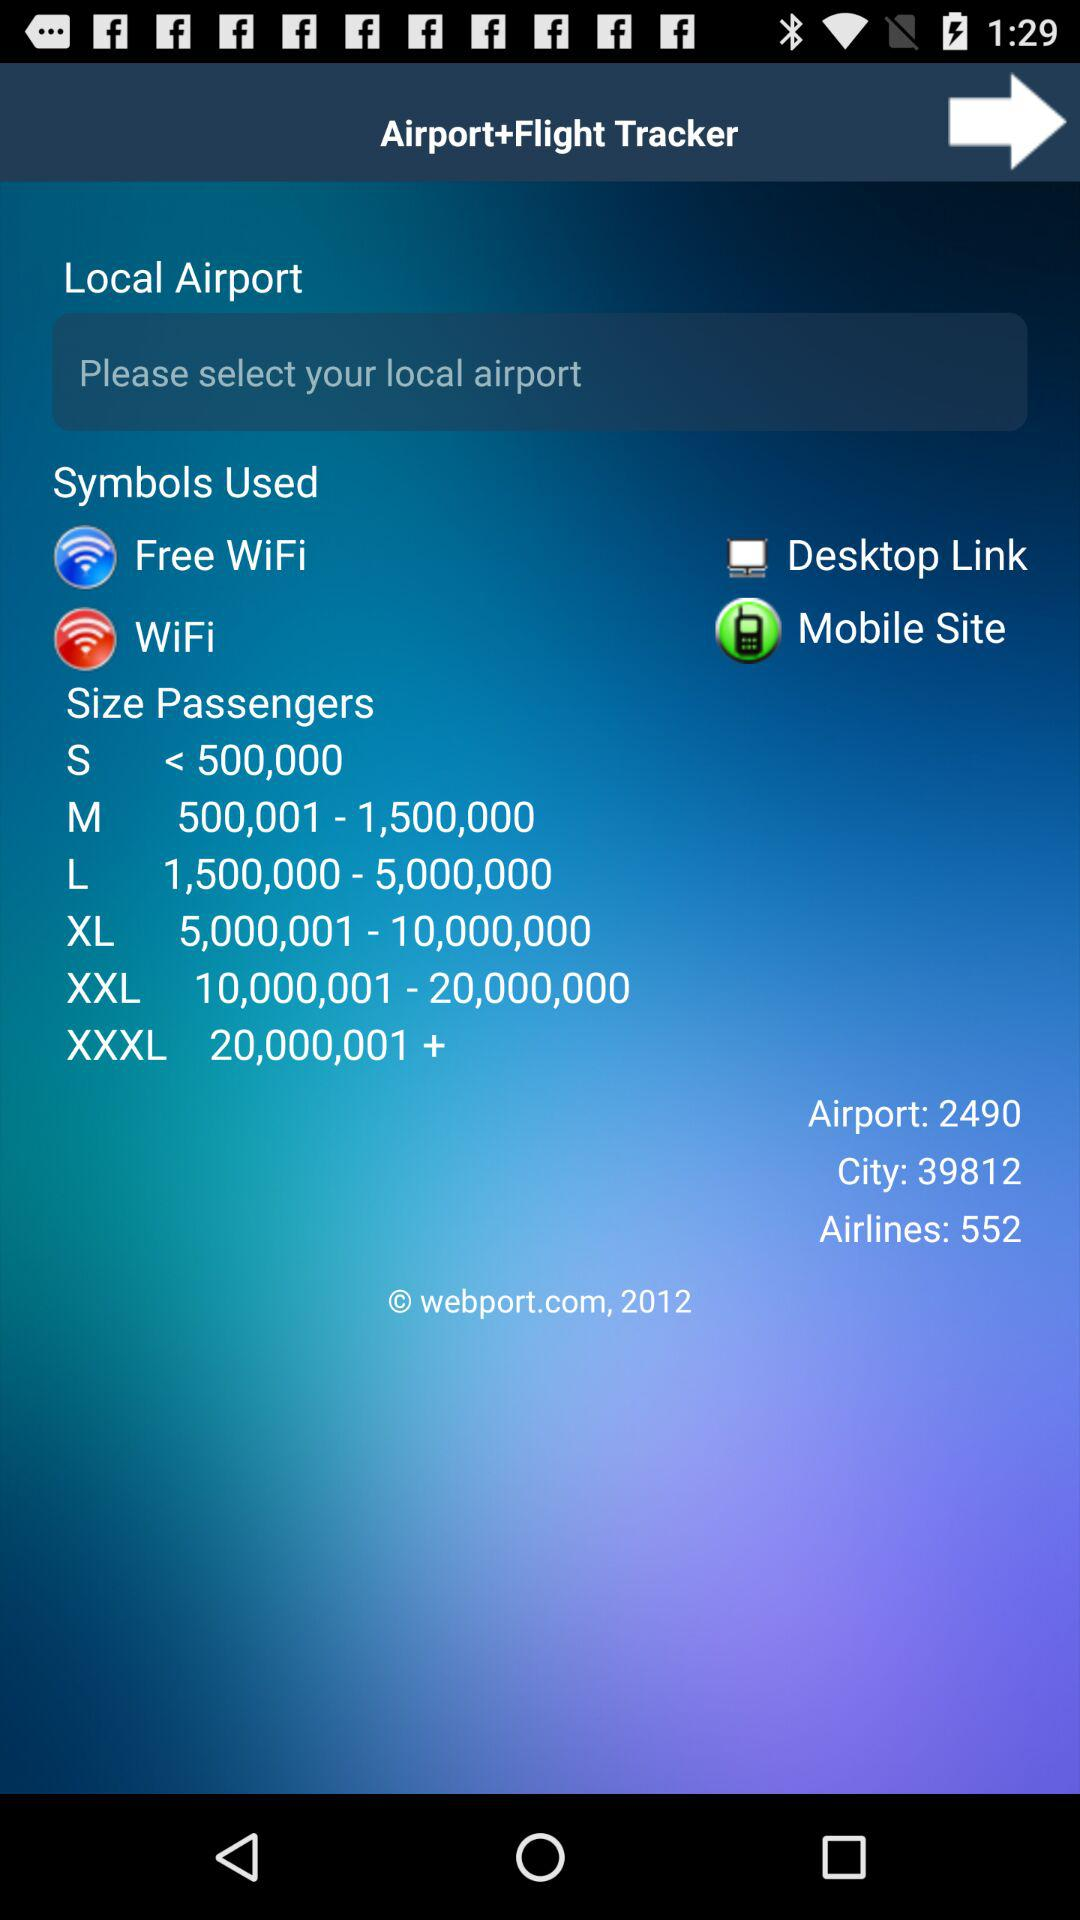What is the range of passengers whose size is XL? The range of passengers whose size is XL is from 5,000,001 to 10,000,000. 